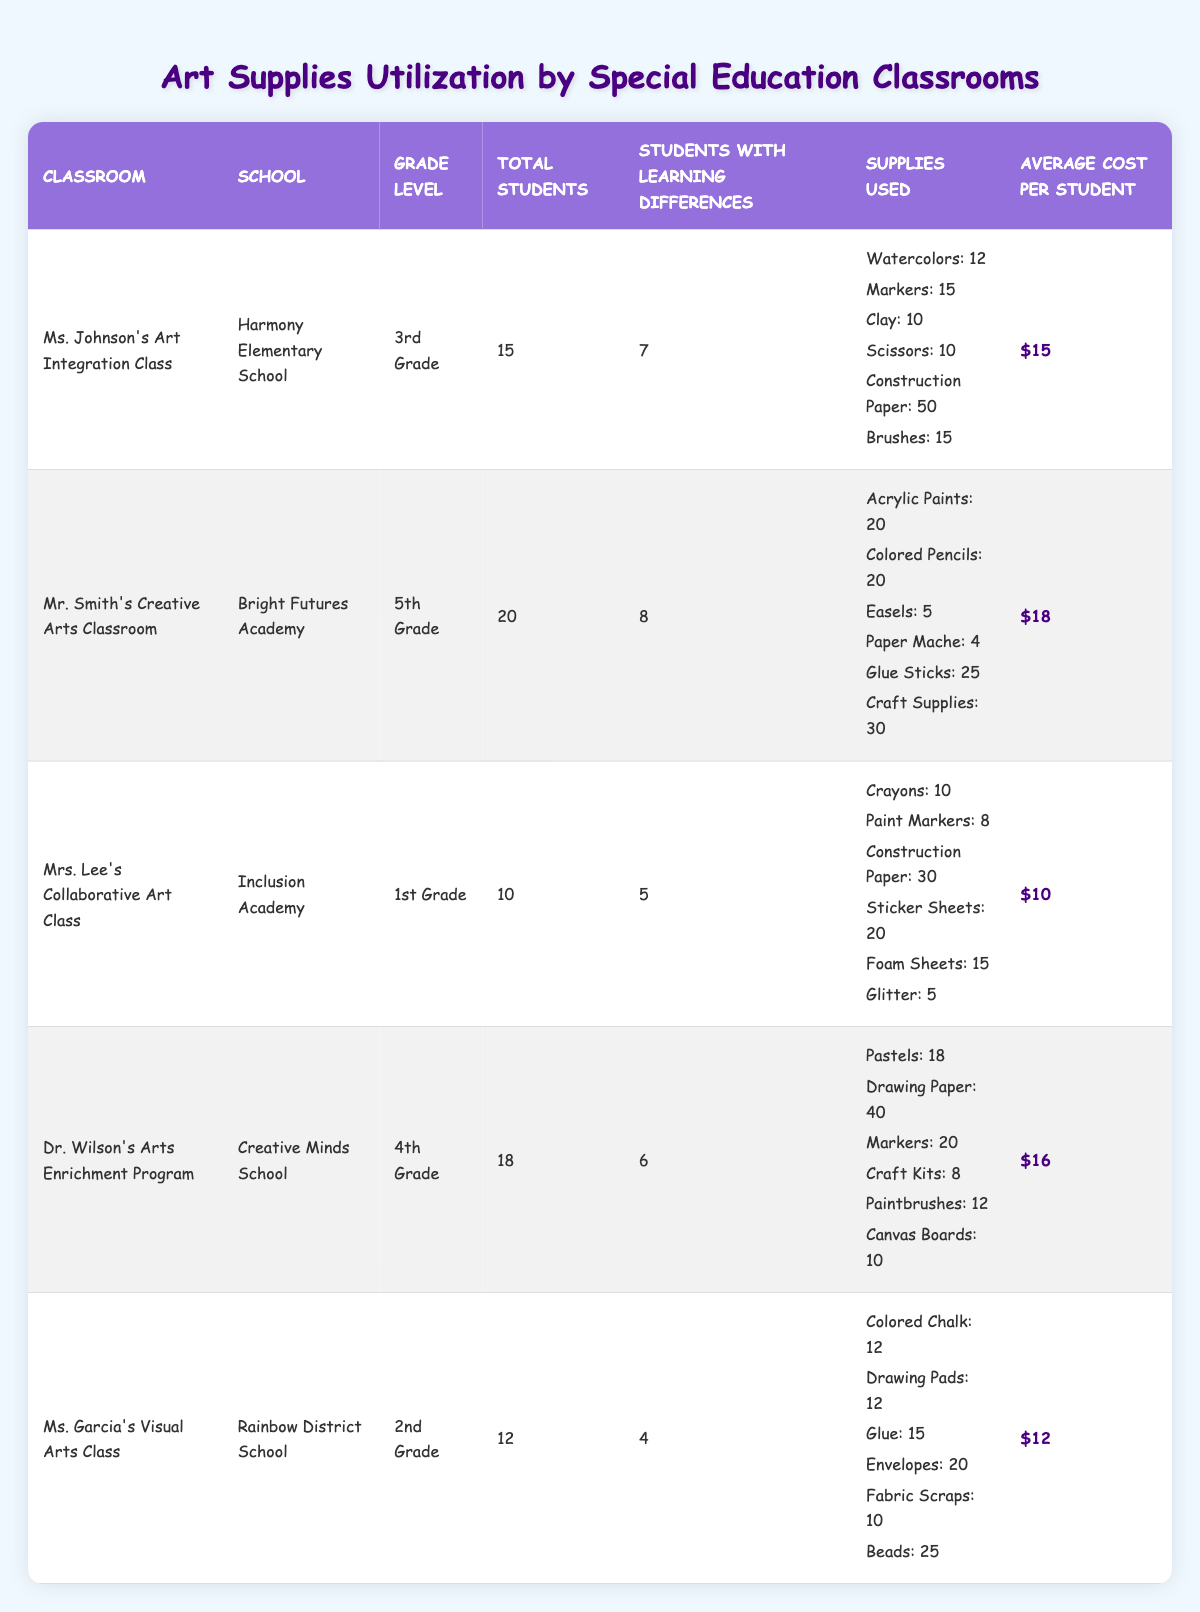What is the total number of students in Ms. Johnson's Art Integration Class? The table shows that Ms. Johnson's class has a total of 15 students listed under the "Total Students" column.
Answer: 15 How many supplies were used in Mr. Smith's Creative Arts Classroom? By adding all the supplies listed in Mr. Smith's row: 20 + 20 + 5 + 4 + 25 + 30 = 104, the total supplies used is 104.
Answer: 104 Did Ms. Garcia's Visual Arts Class have more students with learning differences than Dr. Wilson's Arts Enrichment Program? Ms. Garcia's class has 4 students with learning differences while Dr. Wilson's class has 6. Thus, it is false that Ms. Garcia's class had more.
Answer: No What is the average cost per student in Mrs. Lee's Collaborative Art Class? The table states that the average cost per student in Mrs. Lee's class is $10.
Answer: $10 Which classroom used the highest total number of art supplies? Analyzing the total supplies used: Ms. Johnson's class used 102, Mr. Smith's class used 104, Mrs. Lee's class used 88, Dr. Wilson's class used 108, and Ms. Garcia's class used 94, thus Dr. Wilson's Arts Enrichment Program has the highest total.
Answer: Dr. Wilson's Arts Enrichment Program What is the difference in average cost per student between Mr. Smith's and Mrs. Lee's classrooms? Average cost per student for Mr. Smith's class is $18 and for Mrs. Lee's class is $10. The difference is $18 - $10 = $8.
Answer: $8 In which grades are the classes that used more than 50 supplies? Reviewing the data, only Ms. Johnson's Art Integration Class (50) and Mr. Smith's Creative Arts Classroom (104) are above 50. Ms. Johnson's is 3rd grade, and Mr. Smith's is 5th grade. Therefore, both 3rd and 5th grades have classes that meet the criteria.
Answer: 3rd and 5th grades How many total students have learning differences across all classrooms? By summing the numbers of students with learning differences in each classroom: 7 + 8 + 5 + 6 + 4 = 30 students have learning differences in total.
Answer: 30 Which school has the smallest class in terms of total students? Looking at the total students, Mrs. Lee's class at Inclusion Academy has 10 students, which is less than any other class listed.
Answer: Inclusion Academy How many more supplies did Dr. Wilson's class use compared to Ms. Garcia's class? Dr. Wilson's class used 108 total supplies and Ms. Garcia's class used 94 total supplies. The difference is 108 - 94 = 14 supplies.
Answer: 14 Is it true that Ms. Johnson's Art Integration Class has a student cost lower than Mr. Smith's Creative Arts Classroom? The average cost per student in Ms. Johnson's class is $15, and in Mr. Smith's class, it is $18. Since $15 is less than $18, this statement is true.
Answer: Yes 